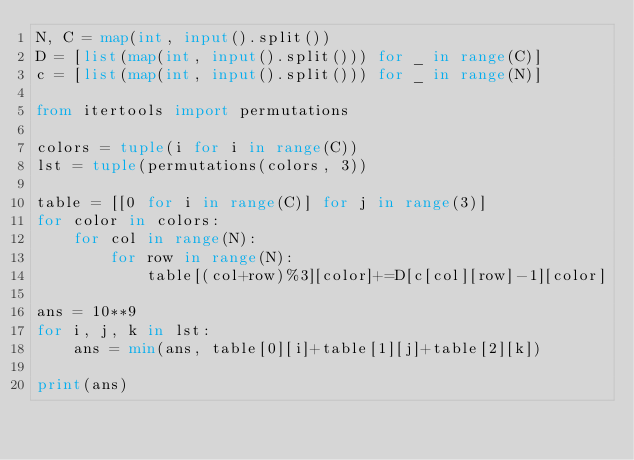Convert code to text. <code><loc_0><loc_0><loc_500><loc_500><_Python_>N, C = map(int, input().split())
D = [list(map(int, input().split())) for _ in range(C)]
c = [list(map(int, input().split())) for _ in range(N)]

from itertools import permutations

colors = tuple(i for i in range(C))
lst = tuple(permutations(colors, 3))

table = [[0 for i in range(C)] for j in range(3)]
for color in colors:
    for col in range(N):
        for row in range(N):
            table[(col+row)%3][color]+=D[c[col][row]-1][color]
            
ans = 10**9    
for i, j, k in lst:
    ans = min(ans, table[0][i]+table[1][j]+table[2][k])

print(ans)</code> 